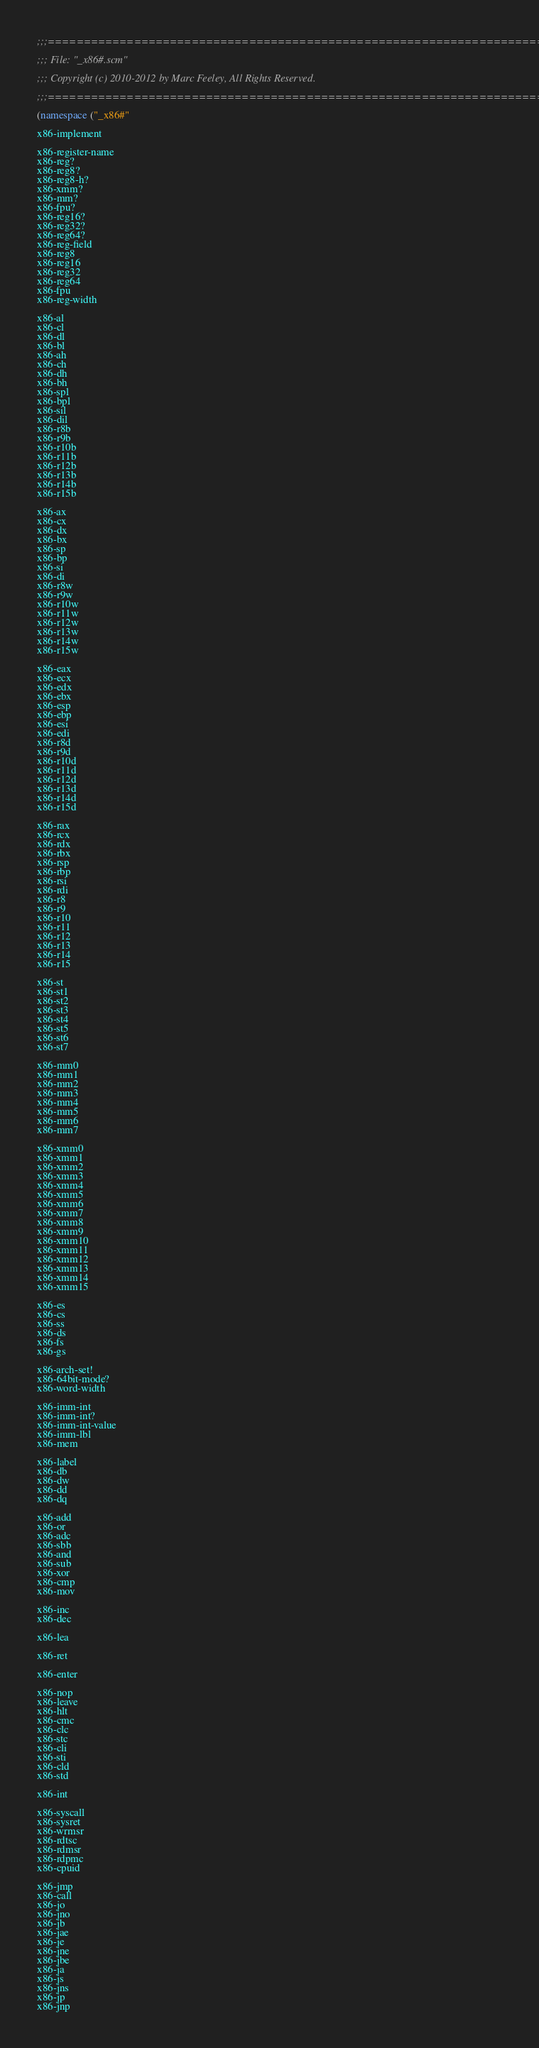Convert code to text. <code><loc_0><loc_0><loc_500><loc_500><_Scheme_>;;;============================================================================

;;; File: "_x86#.scm"

;;; Copyright (c) 2010-2012 by Marc Feeley, All Rights Reserved.

;;;============================================================================

(namespace ("_x86#"

x86-implement

x86-register-name
x86-reg?
x86-reg8?
x86-reg8-h?
x86-xmm?
x86-mm?
x86-fpu?
x86-reg16?
x86-reg32?
x86-reg64?
x86-reg-field
x86-reg8
x86-reg16
x86-reg32
x86-reg64
x86-fpu
x86-reg-width

x86-al
x86-cl
x86-dl
x86-bl
x86-ah
x86-ch
x86-dh
x86-bh
x86-spl
x86-bpl
x86-sil
x86-dil
x86-r8b
x86-r9b
x86-r10b
x86-r11b
x86-r12b
x86-r13b
x86-r14b
x86-r15b

x86-ax
x86-cx
x86-dx
x86-bx
x86-sp
x86-bp
x86-si
x86-di
x86-r8w
x86-r9w
x86-r10w
x86-r11w
x86-r12w
x86-r13w
x86-r14w
x86-r15w

x86-eax
x86-ecx
x86-edx
x86-ebx
x86-esp
x86-ebp
x86-esi
x86-edi
x86-r8d
x86-r9d
x86-r10d
x86-r11d
x86-r12d
x86-r13d
x86-r14d
x86-r15d

x86-rax
x86-rcx
x86-rdx
x86-rbx
x86-rsp
x86-rbp
x86-rsi
x86-rdi
x86-r8
x86-r9
x86-r10
x86-r11
x86-r12
x86-r13
x86-r14
x86-r15

x86-st
x86-st1
x86-st2
x86-st3
x86-st4
x86-st5
x86-st6
x86-st7

x86-mm0
x86-mm1
x86-mm2
x86-mm3
x86-mm4
x86-mm5
x86-mm6
x86-mm7

x86-xmm0
x86-xmm1
x86-xmm2
x86-xmm3
x86-xmm4
x86-xmm5
x86-xmm6
x86-xmm7
x86-xmm8
x86-xmm9
x86-xmm10
x86-xmm11
x86-xmm12
x86-xmm13
x86-xmm14
x86-xmm15

x86-es
x86-cs
x86-ss
x86-ds
x86-fs
x86-gs

x86-arch-set!
x86-64bit-mode?
x86-word-width

x86-imm-int
x86-imm-int?
x86-imm-int-value
x86-imm-lbl
x86-mem

x86-label
x86-db
x86-dw
x86-dd
x86-dq

x86-add
x86-or
x86-adc
x86-sbb
x86-and
x86-sub
x86-xor
x86-cmp
x86-mov

x86-inc
x86-dec

x86-lea

x86-ret

x86-enter

x86-nop
x86-leave
x86-hlt
x86-cmc
x86-clc
x86-stc
x86-cli
x86-sti
x86-cld
x86-std

x86-int

x86-syscall
x86-sysret
x86-wrmsr
x86-rdtsc
x86-rdmsr
x86-rdpmc
x86-cpuid

x86-jmp
x86-call
x86-jo
x86-jno
x86-jb
x86-jae
x86-je
x86-jne
x86-jbe
x86-ja
x86-js
x86-jns
x86-jp
x86-jnp</code> 